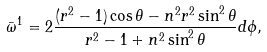Convert formula to latex. <formula><loc_0><loc_0><loc_500><loc_500>\bar { \omega } ^ { 1 } = 2 \frac { ( r ^ { 2 } - 1 ) \cos \theta - n ^ { 2 } r ^ { 2 } \sin ^ { 2 } \theta } { r ^ { 2 } - 1 + n ^ { 2 } \sin ^ { 2 } \theta } d \phi ,</formula> 